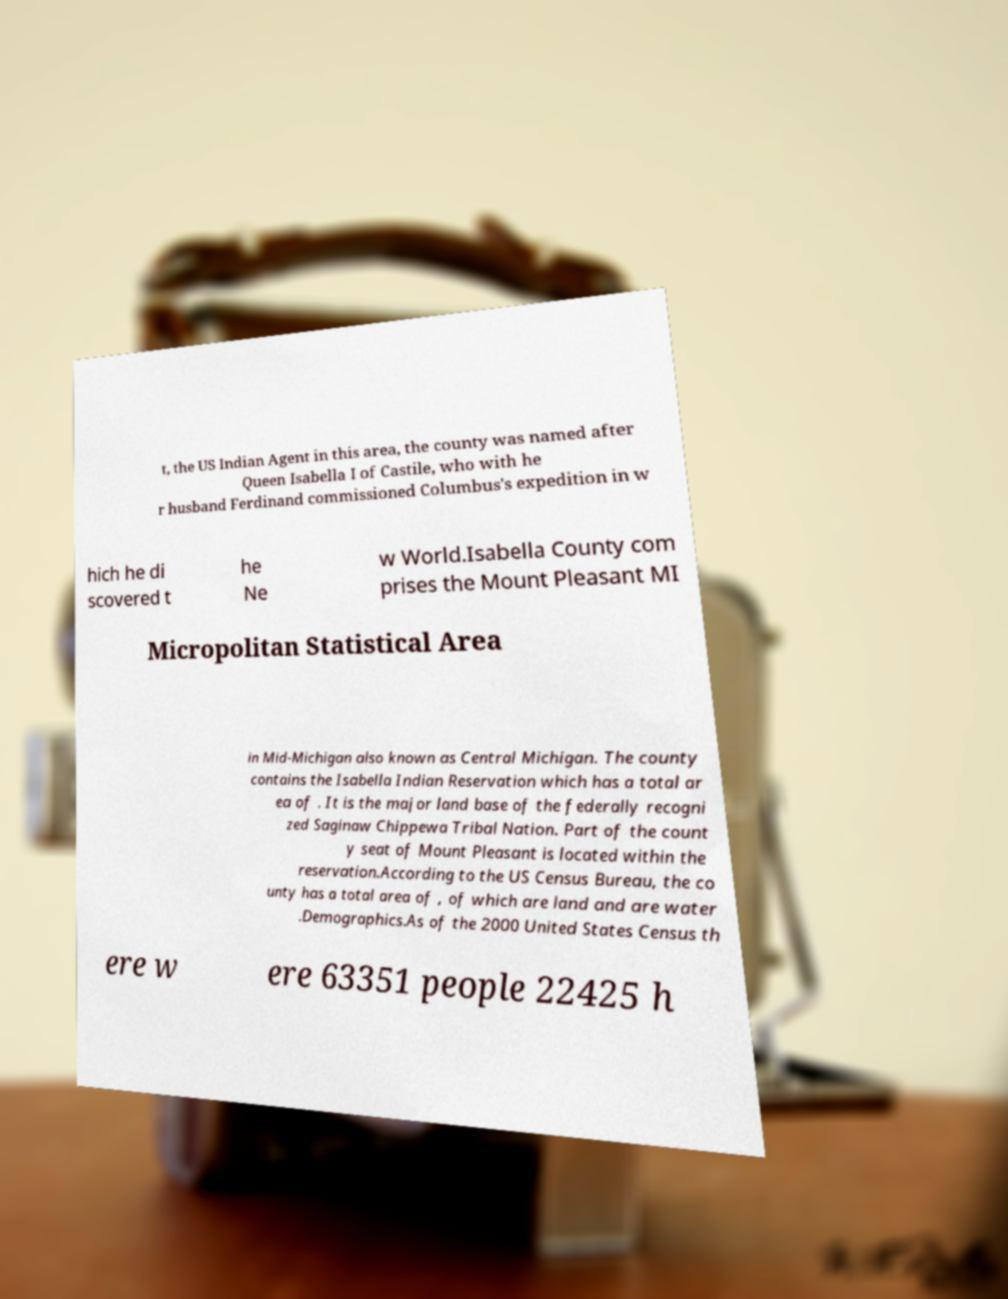Could you extract and type out the text from this image? t, the US Indian Agent in this area, the county was named after Queen Isabella I of Castile, who with he r husband Ferdinand commissioned Columbus's expedition in w hich he di scovered t he Ne w World.Isabella County com prises the Mount Pleasant MI Micropolitan Statistical Area in Mid-Michigan also known as Central Michigan. The county contains the Isabella Indian Reservation which has a total ar ea of . It is the major land base of the federally recogni zed Saginaw Chippewa Tribal Nation. Part of the count y seat of Mount Pleasant is located within the reservation.According to the US Census Bureau, the co unty has a total area of , of which are land and are water .Demographics.As of the 2000 United States Census th ere w ere 63351 people 22425 h 